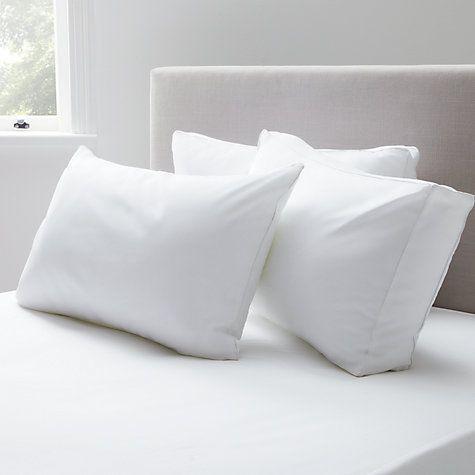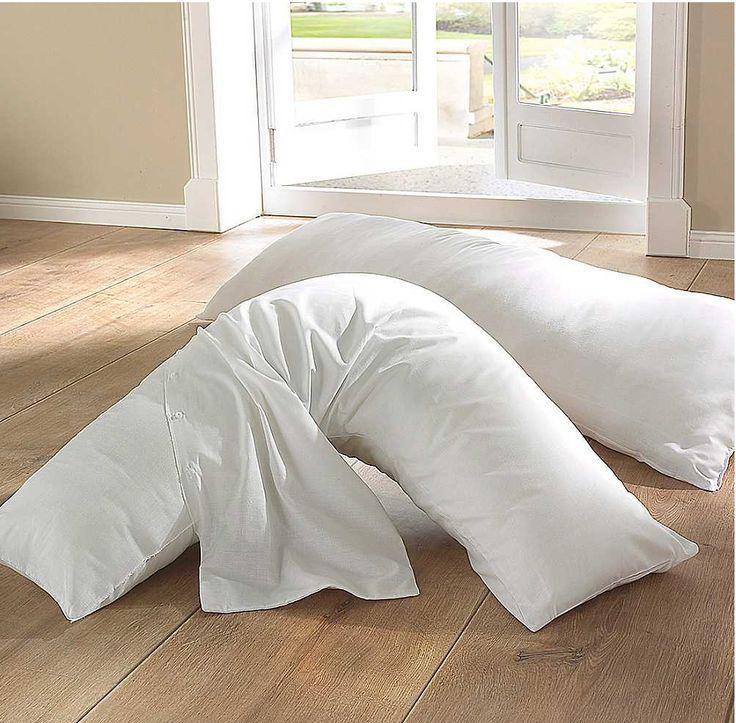The first image is the image on the left, the second image is the image on the right. Analyze the images presented: Is the assertion "Every photo features less than four white pillows all displayed inside a home." valid? Answer yes or no. Yes. 